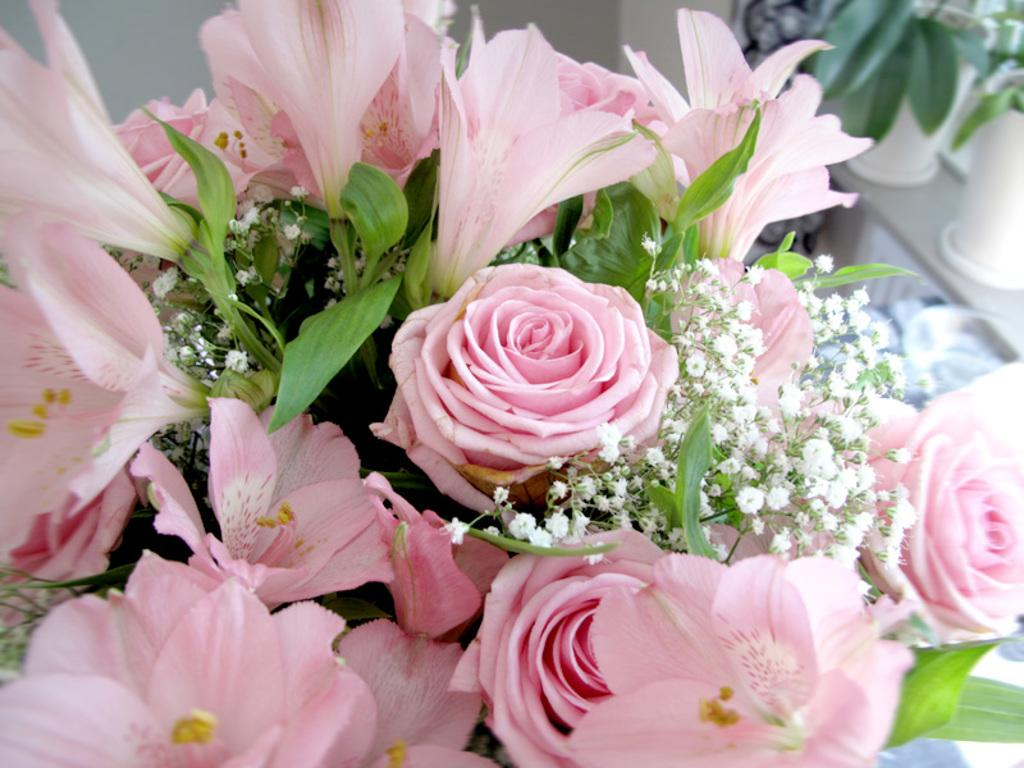What color are the flowers in the image? The flowers in the image are pink. What color are the leaves in the image? The leaves in the image are green. How would you describe the clarity of the image? The image is slightly blurry in the background. Where is the quince located in the image? There is no quince present in the image. What type of market can be seen in the background of the image? There is no market visible in the image; it features flowers and leaves. 